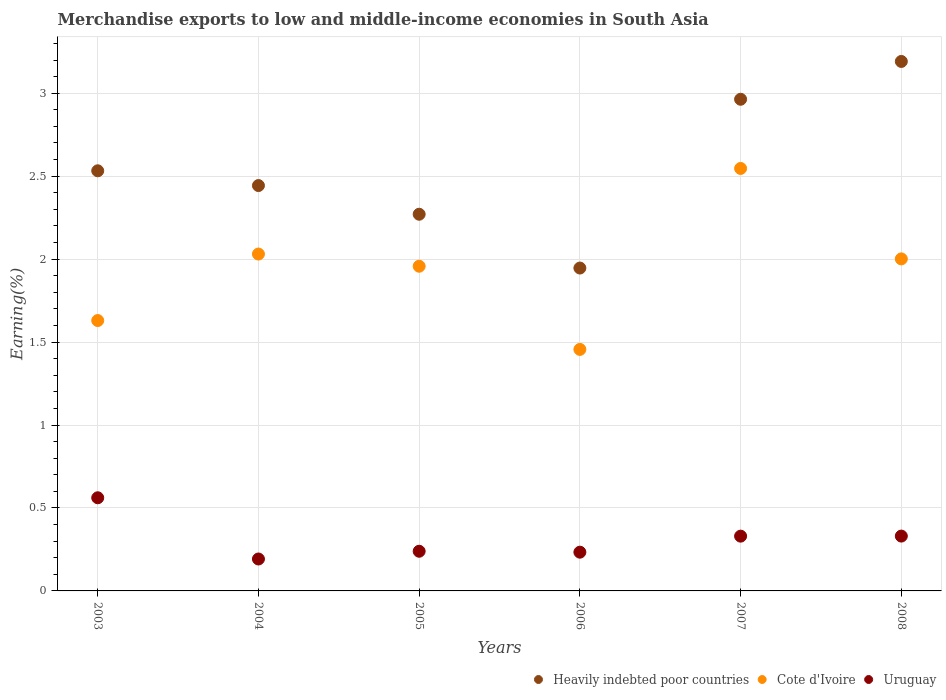Is the number of dotlines equal to the number of legend labels?
Offer a very short reply. Yes. What is the percentage of amount earned from merchandise exports in Uruguay in 2005?
Offer a very short reply. 0.24. Across all years, what is the maximum percentage of amount earned from merchandise exports in Heavily indebted poor countries?
Your response must be concise. 3.19. Across all years, what is the minimum percentage of amount earned from merchandise exports in Cote d'Ivoire?
Offer a very short reply. 1.46. In which year was the percentage of amount earned from merchandise exports in Cote d'Ivoire maximum?
Your response must be concise. 2007. In which year was the percentage of amount earned from merchandise exports in Uruguay minimum?
Keep it short and to the point. 2004. What is the total percentage of amount earned from merchandise exports in Cote d'Ivoire in the graph?
Your answer should be very brief. 11.62. What is the difference between the percentage of amount earned from merchandise exports in Cote d'Ivoire in 2007 and that in 2008?
Offer a terse response. 0.55. What is the difference between the percentage of amount earned from merchandise exports in Cote d'Ivoire in 2006 and the percentage of amount earned from merchandise exports in Heavily indebted poor countries in 2004?
Make the answer very short. -0.99. What is the average percentage of amount earned from merchandise exports in Heavily indebted poor countries per year?
Keep it short and to the point. 2.56. In the year 2007, what is the difference between the percentage of amount earned from merchandise exports in Uruguay and percentage of amount earned from merchandise exports in Heavily indebted poor countries?
Your answer should be compact. -2.63. In how many years, is the percentage of amount earned from merchandise exports in Cote d'Ivoire greater than 1 %?
Your answer should be compact. 6. What is the ratio of the percentage of amount earned from merchandise exports in Cote d'Ivoire in 2004 to that in 2006?
Keep it short and to the point. 1.39. Is the percentage of amount earned from merchandise exports in Uruguay in 2003 less than that in 2006?
Keep it short and to the point. No. What is the difference between the highest and the second highest percentage of amount earned from merchandise exports in Uruguay?
Keep it short and to the point. 0.23. What is the difference between the highest and the lowest percentage of amount earned from merchandise exports in Cote d'Ivoire?
Provide a short and direct response. 1.09. In how many years, is the percentage of amount earned from merchandise exports in Cote d'Ivoire greater than the average percentage of amount earned from merchandise exports in Cote d'Ivoire taken over all years?
Offer a very short reply. 4. Is the percentage of amount earned from merchandise exports in Cote d'Ivoire strictly greater than the percentage of amount earned from merchandise exports in Uruguay over the years?
Keep it short and to the point. Yes. Is the percentage of amount earned from merchandise exports in Cote d'Ivoire strictly less than the percentage of amount earned from merchandise exports in Heavily indebted poor countries over the years?
Provide a succinct answer. Yes. How many years are there in the graph?
Your answer should be very brief. 6. What is the difference between two consecutive major ticks on the Y-axis?
Keep it short and to the point. 0.5. Does the graph contain grids?
Your response must be concise. Yes. What is the title of the graph?
Your response must be concise. Merchandise exports to low and middle-income economies in South Asia. What is the label or title of the Y-axis?
Keep it short and to the point. Earning(%). What is the Earning(%) in Heavily indebted poor countries in 2003?
Offer a very short reply. 2.53. What is the Earning(%) of Cote d'Ivoire in 2003?
Give a very brief answer. 1.63. What is the Earning(%) in Uruguay in 2003?
Keep it short and to the point. 0.56. What is the Earning(%) in Heavily indebted poor countries in 2004?
Offer a very short reply. 2.44. What is the Earning(%) in Cote d'Ivoire in 2004?
Offer a very short reply. 2.03. What is the Earning(%) of Uruguay in 2004?
Your answer should be compact. 0.19. What is the Earning(%) in Heavily indebted poor countries in 2005?
Keep it short and to the point. 2.27. What is the Earning(%) in Cote d'Ivoire in 2005?
Your answer should be compact. 1.96. What is the Earning(%) of Uruguay in 2005?
Your answer should be compact. 0.24. What is the Earning(%) in Heavily indebted poor countries in 2006?
Your answer should be very brief. 1.95. What is the Earning(%) in Cote d'Ivoire in 2006?
Your answer should be compact. 1.46. What is the Earning(%) in Uruguay in 2006?
Provide a succinct answer. 0.23. What is the Earning(%) of Heavily indebted poor countries in 2007?
Provide a short and direct response. 2.96. What is the Earning(%) in Cote d'Ivoire in 2007?
Provide a short and direct response. 2.55. What is the Earning(%) of Uruguay in 2007?
Offer a very short reply. 0.33. What is the Earning(%) in Heavily indebted poor countries in 2008?
Your answer should be very brief. 3.19. What is the Earning(%) of Cote d'Ivoire in 2008?
Provide a short and direct response. 2. What is the Earning(%) of Uruguay in 2008?
Your response must be concise. 0.33. Across all years, what is the maximum Earning(%) of Heavily indebted poor countries?
Give a very brief answer. 3.19. Across all years, what is the maximum Earning(%) of Cote d'Ivoire?
Your answer should be very brief. 2.55. Across all years, what is the maximum Earning(%) in Uruguay?
Offer a very short reply. 0.56. Across all years, what is the minimum Earning(%) in Heavily indebted poor countries?
Provide a succinct answer. 1.95. Across all years, what is the minimum Earning(%) in Cote d'Ivoire?
Offer a terse response. 1.46. Across all years, what is the minimum Earning(%) in Uruguay?
Offer a terse response. 0.19. What is the total Earning(%) of Heavily indebted poor countries in the graph?
Make the answer very short. 15.35. What is the total Earning(%) of Cote d'Ivoire in the graph?
Offer a very short reply. 11.62. What is the total Earning(%) in Uruguay in the graph?
Your answer should be very brief. 1.89. What is the difference between the Earning(%) of Heavily indebted poor countries in 2003 and that in 2004?
Keep it short and to the point. 0.09. What is the difference between the Earning(%) of Cote d'Ivoire in 2003 and that in 2004?
Provide a short and direct response. -0.4. What is the difference between the Earning(%) in Uruguay in 2003 and that in 2004?
Provide a succinct answer. 0.37. What is the difference between the Earning(%) in Heavily indebted poor countries in 2003 and that in 2005?
Provide a succinct answer. 0.26. What is the difference between the Earning(%) of Cote d'Ivoire in 2003 and that in 2005?
Make the answer very short. -0.33. What is the difference between the Earning(%) in Uruguay in 2003 and that in 2005?
Offer a very short reply. 0.32. What is the difference between the Earning(%) of Heavily indebted poor countries in 2003 and that in 2006?
Keep it short and to the point. 0.59. What is the difference between the Earning(%) of Cote d'Ivoire in 2003 and that in 2006?
Provide a short and direct response. 0.17. What is the difference between the Earning(%) in Uruguay in 2003 and that in 2006?
Give a very brief answer. 0.33. What is the difference between the Earning(%) in Heavily indebted poor countries in 2003 and that in 2007?
Provide a short and direct response. -0.43. What is the difference between the Earning(%) in Cote d'Ivoire in 2003 and that in 2007?
Your answer should be compact. -0.92. What is the difference between the Earning(%) of Uruguay in 2003 and that in 2007?
Your response must be concise. 0.23. What is the difference between the Earning(%) in Heavily indebted poor countries in 2003 and that in 2008?
Provide a succinct answer. -0.66. What is the difference between the Earning(%) of Cote d'Ivoire in 2003 and that in 2008?
Your response must be concise. -0.37. What is the difference between the Earning(%) of Uruguay in 2003 and that in 2008?
Make the answer very short. 0.23. What is the difference between the Earning(%) in Heavily indebted poor countries in 2004 and that in 2005?
Ensure brevity in your answer.  0.17. What is the difference between the Earning(%) of Cote d'Ivoire in 2004 and that in 2005?
Offer a terse response. 0.07. What is the difference between the Earning(%) of Uruguay in 2004 and that in 2005?
Your answer should be very brief. -0.05. What is the difference between the Earning(%) in Heavily indebted poor countries in 2004 and that in 2006?
Provide a short and direct response. 0.5. What is the difference between the Earning(%) in Cote d'Ivoire in 2004 and that in 2006?
Your response must be concise. 0.57. What is the difference between the Earning(%) in Uruguay in 2004 and that in 2006?
Your answer should be very brief. -0.04. What is the difference between the Earning(%) of Heavily indebted poor countries in 2004 and that in 2007?
Your answer should be compact. -0.52. What is the difference between the Earning(%) of Cote d'Ivoire in 2004 and that in 2007?
Give a very brief answer. -0.52. What is the difference between the Earning(%) in Uruguay in 2004 and that in 2007?
Make the answer very short. -0.14. What is the difference between the Earning(%) in Heavily indebted poor countries in 2004 and that in 2008?
Offer a very short reply. -0.75. What is the difference between the Earning(%) in Cote d'Ivoire in 2004 and that in 2008?
Give a very brief answer. 0.03. What is the difference between the Earning(%) of Uruguay in 2004 and that in 2008?
Provide a succinct answer. -0.14. What is the difference between the Earning(%) of Heavily indebted poor countries in 2005 and that in 2006?
Provide a short and direct response. 0.32. What is the difference between the Earning(%) of Cote d'Ivoire in 2005 and that in 2006?
Your answer should be very brief. 0.5. What is the difference between the Earning(%) in Uruguay in 2005 and that in 2006?
Ensure brevity in your answer.  0.01. What is the difference between the Earning(%) of Heavily indebted poor countries in 2005 and that in 2007?
Provide a succinct answer. -0.69. What is the difference between the Earning(%) of Cote d'Ivoire in 2005 and that in 2007?
Your response must be concise. -0.59. What is the difference between the Earning(%) in Uruguay in 2005 and that in 2007?
Your answer should be compact. -0.09. What is the difference between the Earning(%) of Heavily indebted poor countries in 2005 and that in 2008?
Your answer should be very brief. -0.92. What is the difference between the Earning(%) of Cote d'Ivoire in 2005 and that in 2008?
Offer a very short reply. -0.04. What is the difference between the Earning(%) of Uruguay in 2005 and that in 2008?
Keep it short and to the point. -0.09. What is the difference between the Earning(%) in Heavily indebted poor countries in 2006 and that in 2007?
Make the answer very short. -1.02. What is the difference between the Earning(%) of Cote d'Ivoire in 2006 and that in 2007?
Your answer should be very brief. -1.09. What is the difference between the Earning(%) in Uruguay in 2006 and that in 2007?
Give a very brief answer. -0.1. What is the difference between the Earning(%) in Heavily indebted poor countries in 2006 and that in 2008?
Your response must be concise. -1.25. What is the difference between the Earning(%) in Cote d'Ivoire in 2006 and that in 2008?
Keep it short and to the point. -0.55. What is the difference between the Earning(%) in Uruguay in 2006 and that in 2008?
Give a very brief answer. -0.1. What is the difference between the Earning(%) of Heavily indebted poor countries in 2007 and that in 2008?
Provide a short and direct response. -0.23. What is the difference between the Earning(%) of Cote d'Ivoire in 2007 and that in 2008?
Make the answer very short. 0.55. What is the difference between the Earning(%) in Uruguay in 2007 and that in 2008?
Your answer should be very brief. -0. What is the difference between the Earning(%) of Heavily indebted poor countries in 2003 and the Earning(%) of Cote d'Ivoire in 2004?
Provide a short and direct response. 0.5. What is the difference between the Earning(%) in Heavily indebted poor countries in 2003 and the Earning(%) in Uruguay in 2004?
Your answer should be very brief. 2.34. What is the difference between the Earning(%) in Cote d'Ivoire in 2003 and the Earning(%) in Uruguay in 2004?
Offer a very short reply. 1.44. What is the difference between the Earning(%) in Heavily indebted poor countries in 2003 and the Earning(%) in Cote d'Ivoire in 2005?
Offer a very short reply. 0.58. What is the difference between the Earning(%) of Heavily indebted poor countries in 2003 and the Earning(%) of Uruguay in 2005?
Provide a short and direct response. 2.29. What is the difference between the Earning(%) of Cote d'Ivoire in 2003 and the Earning(%) of Uruguay in 2005?
Give a very brief answer. 1.39. What is the difference between the Earning(%) in Heavily indebted poor countries in 2003 and the Earning(%) in Cote d'Ivoire in 2006?
Offer a terse response. 1.08. What is the difference between the Earning(%) of Heavily indebted poor countries in 2003 and the Earning(%) of Uruguay in 2006?
Make the answer very short. 2.3. What is the difference between the Earning(%) in Cote d'Ivoire in 2003 and the Earning(%) in Uruguay in 2006?
Offer a terse response. 1.4. What is the difference between the Earning(%) in Heavily indebted poor countries in 2003 and the Earning(%) in Cote d'Ivoire in 2007?
Provide a short and direct response. -0.01. What is the difference between the Earning(%) of Heavily indebted poor countries in 2003 and the Earning(%) of Uruguay in 2007?
Keep it short and to the point. 2.2. What is the difference between the Earning(%) in Cote d'Ivoire in 2003 and the Earning(%) in Uruguay in 2007?
Give a very brief answer. 1.3. What is the difference between the Earning(%) of Heavily indebted poor countries in 2003 and the Earning(%) of Cote d'Ivoire in 2008?
Keep it short and to the point. 0.53. What is the difference between the Earning(%) in Heavily indebted poor countries in 2003 and the Earning(%) in Uruguay in 2008?
Give a very brief answer. 2.2. What is the difference between the Earning(%) of Cote d'Ivoire in 2003 and the Earning(%) of Uruguay in 2008?
Provide a succinct answer. 1.3. What is the difference between the Earning(%) in Heavily indebted poor countries in 2004 and the Earning(%) in Cote d'Ivoire in 2005?
Ensure brevity in your answer.  0.49. What is the difference between the Earning(%) of Heavily indebted poor countries in 2004 and the Earning(%) of Uruguay in 2005?
Offer a very short reply. 2.2. What is the difference between the Earning(%) in Cote d'Ivoire in 2004 and the Earning(%) in Uruguay in 2005?
Provide a short and direct response. 1.79. What is the difference between the Earning(%) in Heavily indebted poor countries in 2004 and the Earning(%) in Cote d'Ivoire in 2006?
Keep it short and to the point. 0.99. What is the difference between the Earning(%) of Heavily indebted poor countries in 2004 and the Earning(%) of Uruguay in 2006?
Your response must be concise. 2.21. What is the difference between the Earning(%) in Cote d'Ivoire in 2004 and the Earning(%) in Uruguay in 2006?
Offer a terse response. 1.8. What is the difference between the Earning(%) in Heavily indebted poor countries in 2004 and the Earning(%) in Cote d'Ivoire in 2007?
Give a very brief answer. -0.1. What is the difference between the Earning(%) in Heavily indebted poor countries in 2004 and the Earning(%) in Uruguay in 2007?
Give a very brief answer. 2.11. What is the difference between the Earning(%) of Cote d'Ivoire in 2004 and the Earning(%) of Uruguay in 2007?
Ensure brevity in your answer.  1.7. What is the difference between the Earning(%) of Heavily indebted poor countries in 2004 and the Earning(%) of Cote d'Ivoire in 2008?
Offer a terse response. 0.44. What is the difference between the Earning(%) of Heavily indebted poor countries in 2004 and the Earning(%) of Uruguay in 2008?
Give a very brief answer. 2.11. What is the difference between the Earning(%) in Cote d'Ivoire in 2004 and the Earning(%) in Uruguay in 2008?
Your response must be concise. 1.7. What is the difference between the Earning(%) of Heavily indebted poor countries in 2005 and the Earning(%) of Cote d'Ivoire in 2006?
Offer a terse response. 0.81. What is the difference between the Earning(%) in Heavily indebted poor countries in 2005 and the Earning(%) in Uruguay in 2006?
Your response must be concise. 2.04. What is the difference between the Earning(%) in Cote d'Ivoire in 2005 and the Earning(%) in Uruguay in 2006?
Your answer should be very brief. 1.72. What is the difference between the Earning(%) of Heavily indebted poor countries in 2005 and the Earning(%) of Cote d'Ivoire in 2007?
Your answer should be compact. -0.28. What is the difference between the Earning(%) of Heavily indebted poor countries in 2005 and the Earning(%) of Uruguay in 2007?
Give a very brief answer. 1.94. What is the difference between the Earning(%) in Cote d'Ivoire in 2005 and the Earning(%) in Uruguay in 2007?
Ensure brevity in your answer.  1.63. What is the difference between the Earning(%) of Heavily indebted poor countries in 2005 and the Earning(%) of Cote d'Ivoire in 2008?
Provide a succinct answer. 0.27. What is the difference between the Earning(%) in Heavily indebted poor countries in 2005 and the Earning(%) in Uruguay in 2008?
Make the answer very short. 1.94. What is the difference between the Earning(%) in Cote d'Ivoire in 2005 and the Earning(%) in Uruguay in 2008?
Offer a very short reply. 1.63. What is the difference between the Earning(%) of Heavily indebted poor countries in 2006 and the Earning(%) of Cote d'Ivoire in 2007?
Provide a succinct answer. -0.6. What is the difference between the Earning(%) in Heavily indebted poor countries in 2006 and the Earning(%) in Uruguay in 2007?
Provide a succinct answer. 1.62. What is the difference between the Earning(%) of Cote d'Ivoire in 2006 and the Earning(%) of Uruguay in 2007?
Offer a terse response. 1.13. What is the difference between the Earning(%) of Heavily indebted poor countries in 2006 and the Earning(%) of Cote d'Ivoire in 2008?
Your answer should be compact. -0.06. What is the difference between the Earning(%) of Heavily indebted poor countries in 2006 and the Earning(%) of Uruguay in 2008?
Keep it short and to the point. 1.62. What is the difference between the Earning(%) in Cote d'Ivoire in 2006 and the Earning(%) in Uruguay in 2008?
Your response must be concise. 1.13. What is the difference between the Earning(%) of Heavily indebted poor countries in 2007 and the Earning(%) of Cote d'Ivoire in 2008?
Make the answer very short. 0.96. What is the difference between the Earning(%) of Heavily indebted poor countries in 2007 and the Earning(%) of Uruguay in 2008?
Offer a very short reply. 2.63. What is the difference between the Earning(%) of Cote d'Ivoire in 2007 and the Earning(%) of Uruguay in 2008?
Give a very brief answer. 2.22. What is the average Earning(%) in Heavily indebted poor countries per year?
Offer a very short reply. 2.56. What is the average Earning(%) of Cote d'Ivoire per year?
Offer a very short reply. 1.94. What is the average Earning(%) in Uruguay per year?
Make the answer very short. 0.31. In the year 2003, what is the difference between the Earning(%) in Heavily indebted poor countries and Earning(%) in Cote d'Ivoire?
Keep it short and to the point. 0.9. In the year 2003, what is the difference between the Earning(%) in Heavily indebted poor countries and Earning(%) in Uruguay?
Ensure brevity in your answer.  1.97. In the year 2003, what is the difference between the Earning(%) of Cote d'Ivoire and Earning(%) of Uruguay?
Provide a short and direct response. 1.07. In the year 2004, what is the difference between the Earning(%) in Heavily indebted poor countries and Earning(%) in Cote d'Ivoire?
Make the answer very short. 0.41. In the year 2004, what is the difference between the Earning(%) of Heavily indebted poor countries and Earning(%) of Uruguay?
Keep it short and to the point. 2.25. In the year 2004, what is the difference between the Earning(%) of Cote d'Ivoire and Earning(%) of Uruguay?
Offer a very short reply. 1.84. In the year 2005, what is the difference between the Earning(%) in Heavily indebted poor countries and Earning(%) in Cote d'Ivoire?
Give a very brief answer. 0.31. In the year 2005, what is the difference between the Earning(%) of Heavily indebted poor countries and Earning(%) of Uruguay?
Your response must be concise. 2.03. In the year 2005, what is the difference between the Earning(%) of Cote d'Ivoire and Earning(%) of Uruguay?
Make the answer very short. 1.72. In the year 2006, what is the difference between the Earning(%) in Heavily indebted poor countries and Earning(%) in Cote d'Ivoire?
Your answer should be compact. 0.49. In the year 2006, what is the difference between the Earning(%) in Heavily indebted poor countries and Earning(%) in Uruguay?
Keep it short and to the point. 1.71. In the year 2006, what is the difference between the Earning(%) of Cote d'Ivoire and Earning(%) of Uruguay?
Make the answer very short. 1.22. In the year 2007, what is the difference between the Earning(%) in Heavily indebted poor countries and Earning(%) in Cote d'Ivoire?
Provide a succinct answer. 0.42. In the year 2007, what is the difference between the Earning(%) in Heavily indebted poor countries and Earning(%) in Uruguay?
Provide a succinct answer. 2.63. In the year 2007, what is the difference between the Earning(%) in Cote d'Ivoire and Earning(%) in Uruguay?
Your answer should be compact. 2.22. In the year 2008, what is the difference between the Earning(%) of Heavily indebted poor countries and Earning(%) of Cote d'Ivoire?
Offer a very short reply. 1.19. In the year 2008, what is the difference between the Earning(%) in Heavily indebted poor countries and Earning(%) in Uruguay?
Make the answer very short. 2.86. In the year 2008, what is the difference between the Earning(%) of Cote d'Ivoire and Earning(%) of Uruguay?
Offer a very short reply. 1.67. What is the ratio of the Earning(%) of Heavily indebted poor countries in 2003 to that in 2004?
Give a very brief answer. 1.04. What is the ratio of the Earning(%) of Cote d'Ivoire in 2003 to that in 2004?
Provide a short and direct response. 0.8. What is the ratio of the Earning(%) of Uruguay in 2003 to that in 2004?
Provide a succinct answer. 2.92. What is the ratio of the Earning(%) of Heavily indebted poor countries in 2003 to that in 2005?
Make the answer very short. 1.12. What is the ratio of the Earning(%) of Cote d'Ivoire in 2003 to that in 2005?
Provide a succinct answer. 0.83. What is the ratio of the Earning(%) in Uruguay in 2003 to that in 2005?
Keep it short and to the point. 2.35. What is the ratio of the Earning(%) in Heavily indebted poor countries in 2003 to that in 2006?
Provide a succinct answer. 1.3. What is the ratio of the Earning(%) of Cote d'Ivoire in 2003 to that in 2006?
Your answer should be very brief. 1.12. What is the ratio of the Earning(%) of Uruguay in 2003 to that in 2006?
Give a very brief answer. 2.4. What is the ratio of the Earning(%) of Heavily indebted poor countries in 2003 to that in 2007?
Your answer should be compact. 0.85. What is the ratio of the Earning(%) in Cote d'Ivoire in 2003 to that in 2007?
Your response must be concise. 0.64. What is the ratio of the Earning(%) of Uruguay in 2003 to that in 2007?
Ensure brevity in your answer.  1.7. What is the ratio of the Earning(%) of Heavily indebted poor countries in 2003 to that in 2008?
Keep it short and to the point. 0.79. What is the ratio of the Earning(%) of Cote d'Ivoire in 2003 to that in 2008?
Provide a succinct answer. 0.81. What is the ratio of the Earning(%) of Uruguay in 2003 to that in 2008?
Make the answer very short. 1.7. What is the ratio of the Earning(%) of Heavily indebted poor countries in 2004 to that in 2005?
Make the answer very short. 1.08. What is the ratio of the Earning(%) in Cote d'Ivoire in 2004 to that in 2005?
Your answer should be very brief. 1.04. What is the ratio of the Earning(%) in Uruguay in 2004 to that in 2005?
Keep it short and to the point. 0.8. What is the ratio of the Earning(%) of Heavily indebted poor countries in 2004 to that in 2006?
Your response must be concise. 1.26. What is the ratio of the Earning(%) in Cote d'Ivoire in 2004 to that in 2006?
Provide a succinct answer. 1.39. What is the ratio of the Earning(%) of Uruguay in 2004 to that in 2006?
Offer a terse response. 0.82. What is the ratio of the Earning(%) in Heavily indebted poor countries in 2004 to that in 2007?
Provide a short and direct response. 0.82. What is the ratio of the Earning(%) of Cote d'Ivoire in 2004 to that in 2007?
Offer a very short reply. 0.8. What is the ratio of the Earning(%) of Uruguay in 2004 to that in 2007?
Your answer should be compact. 0.58. What is the ratio of the Earning(%) in Heavily indebted poor countries in 2004 to that in 2008?
Make the answer very short. 0.77. What is the ratio of the Earning(%) in Cote d'Ivoire in 2004 to that in 2008?
Provide a short and direct response. 1.01. What is the ratio of the Earning(%) in Uruguay in 2004 to that in 2008?
Provide a succinct answer. 0.58. What is the ratio of the Earning(%) of Heavily indebted poor countries in 2005 to that in 2006?
Ensure brevity in your answer.  1.17. What is the ratio of the Earning(%) in Cote d'Ivoire in 2005 to that in 2006?
Make the answer very short. 1.34. What is the ratio of the Earning(%) in Uruguay in 2005 to that in 2006?
Your answer should be compact. 1.02. What is the ratio of the Earning(%) of Heavily indebted poor countries in 2005 to that in 2007?
Offer a very short reply. 0.77. What is the ratio of the Earning(%) in Cote d'Ivoire in 2005 to that in 2007?
Ensure brevity in your answer.  0.77. What is the ratio of the Earning(%) of Uruguay in 2005 to that in 2007?
Give a very brief answer. 0.72. What is the ratio of the Earning(%) in Heavily indebted poor countries in 2005 to that in 2008?
Provide a short and direct response. 0.71. What is the ratio of the Earning(%) of Cote d'Ivoire in 2005 to that in 2008?
Keep it short and to the point. 0.98. What is the ratio of the Earning(%) in Uruguay in 2005 to that in 2008?
Your answer should be compact. 0.72. What is the ratio of the Earning(%) of Heavily indebted poor countries in 2006 to that in 2007?
Keep it short and to the point. 0.66. What is the ratio of the Earning(%) of Cote d'Ivoire in 2006 to that in 2007?
Offer a very short reply. 0.57. What is the ratio of the Earning(%) in Uruguay in 2006 to that in 2007?
Offer a terse response. 0.71. What is the ratio of the Earning(%) in Heavily indebted poor countries in 2006 to that in 2008?
Your response must be concise. 0.61. What is the ratio of the Earning(%) in Cote d'Ivoire in 2006 to that in 2008?
Your answer should be compact. 0.73. What is the ratio of the Earning(%) in Uruguay in 2006 to that in 2008?
Your response must be concise. 0.71. What is the ratio of the Earning(%) in Heavily indebted poor countries in 2007 to that in 2008?
Make the answer very short. 0.93. What is the ratio of the Earning(%) of Cote d'Ivoire in 2007 to that in 2008?
Your response must be concise. 1.27. What is the ratio of the Earning(%) in Uruguay in 2007 to that in 2008?
Your answer should be compact. 1. What is the difference between the highest and the second highest Earning(%) of Heavily indebted poor countries?
Keep it short and to the point. 0.23. What is the difference between the highest and the second highest Earning(%) of Cote d'Ivoire?
Make the answer very short. 0.52. What is the difference between the highest and the second highest Earning(%) of Uruguay?
Your answer should be compact. 0.23. What is the difference between the highest and the lowest Earning(%) of Heavily indebted poor countries?
Keep it short and to the point. 1.25. What is the difference between the highest and the lowest Earning(%) in Cote d'Ivoire?
Offer a very short reply. 1.09. What is the difference between the highest and the lowest Earning(%) in Uruguay?
Keep it short and to the point. 0.37. 